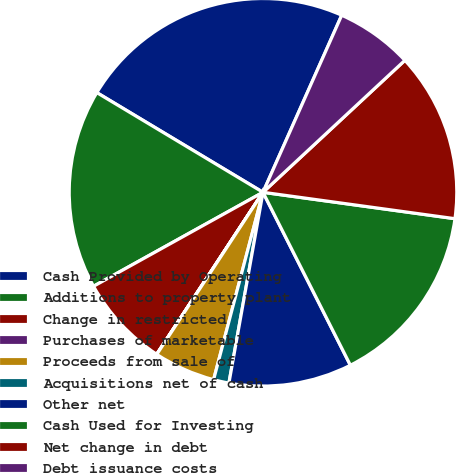Convert chart. <chart><loc_0><loc_0><loc_500><loc_500><pie_chart><fcel>Cash Provided by Operating<fcel>Additions to property plant<fcel>Change in restricted<fcel>Purchases of marketable<fcel>Proceeds from sale of<fcel>Acquisitions net of cash<fcel>Other net<fcel>Cash Used for Investing<fcel>Net change in debt<fcel>Debt issuance costs<nl><fcel>23.06%<fcel>16.66%<fcel>7.7%<fcel>0.01%<fcel>5.13%<fcel>1.29%<fcel>10.26%<fcel>15.38%<fcel>14.1%<fcel>6.42%<nl></chart> 